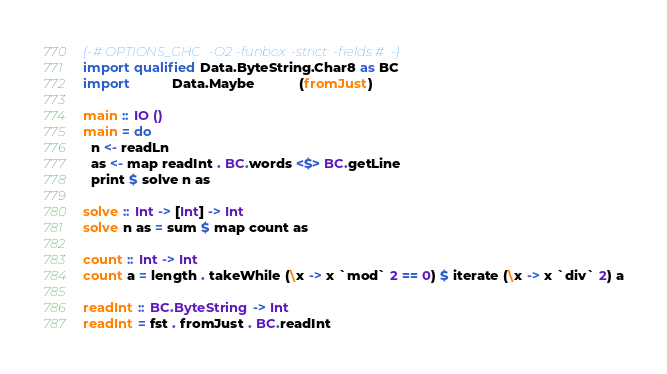<code> <loc_0><loc_0><loc_500><loc_500><_Haskell_>{-# OPTIONS_GHC -O2 -funbox-strict-fields #-}
import qualified Data.ByteString.Char8 as BC
import           Data.Maybe            (fromJust)

main :: IO ()
main = do
  n <- readLn
  as <- map readInt . BC.words <$> BC.getLine
  print $ solve n as

solve :: Int -> [Int] -> Int
solve n as = sum $ map count as

count :: Int -> Int
count a = length . takeWhile (\x -> x `mod` 2 == 0) $ iterate (\x -> x `div` 2) a

readInt :: BC.ByteString -> Int
readInt = fst . fromJust . BC.readInt
</code> 